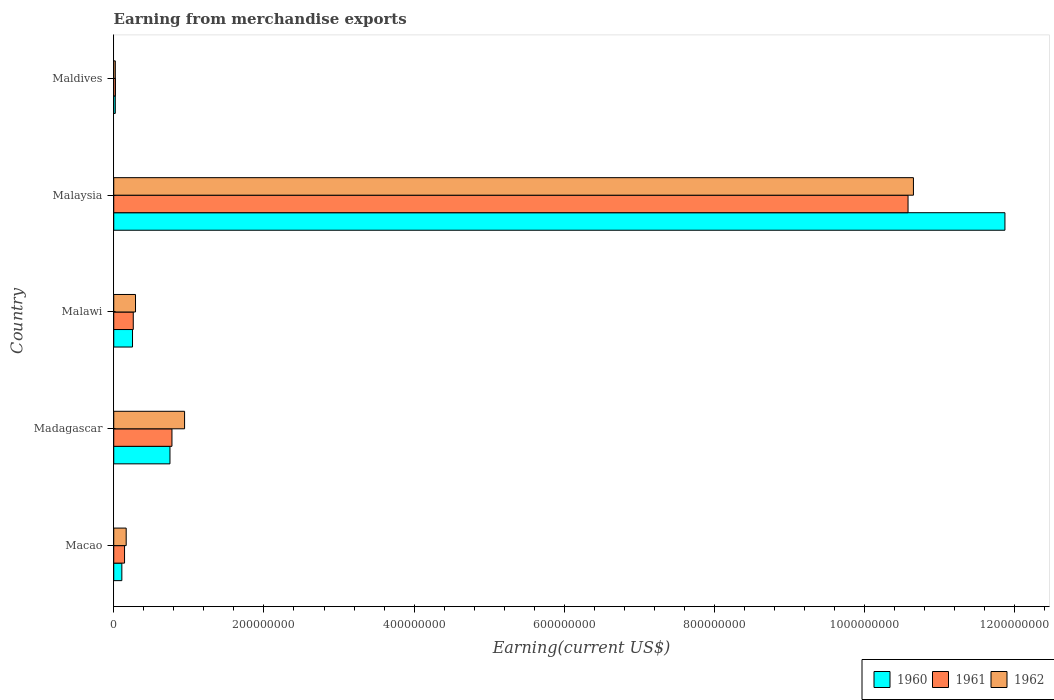How many different coloured bars are there?
Keep it short and to the point. 3. Are the number of bars per tick equal to the number of legend labels?
Provide a short and direct response. Yes. How many bars are there on the 3rd tick from the top?
Keep it short and to the point. 3. What is the label of the 4th group of bars from the top?
Offer a very short reply. Madagascar. What is the amount earned from merchandise exports in 1962 in Malaysia?
Your response must be concise. 1.06e+09. Across all countries, what is the maximum amount earned from merchandise exports in 1962?
Ensure brevity in your answer.  1.06e+09. Across all countries, what is the minimum amount earned from merchandise exports in 1962?
Offer a terse response. 2.08e+06. In which country was the amount earned from merchandise exports in 1960 maximum?
Your answer should be compact. Malaysia. In which country was the amount earned from merchandise exports in 1962 minimum?
Offer a terse response. Maldives. What is the total amount earned from merchandise exports in 1961 in the graph?
Your response must be concise. 1.18e+09. What is the difference between the amount earned from merchandise exports in 1960 in Madagascar and that in Malaysia?
Your response must be concise. -1.11e+09. What is the difference between the amount earned from merchandise exports in 1961 in Macao and the amount earned from merchandise exports in 1962 in Madagascar?
Offer a terse response. -7.99e+07. What is the average amount earned from merchandise exports in 1961 per country?
Your answer should be very brief. 2.36e+08. What is the difference between the amount earned from merchandise exports in 1961 and amount earned from merchandise exports in 1960 in Malaysia?
Offer a terse response. -1.29e+08. In how many countries, is the amount earned from merchandise exports in 1961 greater than 440000000 US$?
Provide a short and direct response. 1. What is the ratio of the amount earned from merchandise exports in 1961 in Macao to that in Malawi?
Keep it short and to the point. 0.55. What is the difference between the highest and the second highest amount earned from merchandise exports in 1962?
Provide a short and direct response. 9.71e+08. What is the difference between the highest and the lowest amount earned from merchandise exports in 1962?
Provide a short and direct response. 1.06e+09. What does the 1st bar from the bottom in Malaysia represents?
Offer a terse response. 1960. How many bars are there?
Make the answer very short. 15. How many countries are there in the graph?
Your response must be concise. 5. Are the values on the major ticks of X-axis written in scientific E-notation?
Provide a short and direct response. No. Does the graph contain any zero values?
Your answer should be very brief. No. Does the graph contain grids?
Offer a very short reply. No. Where does the legend appear in the graph?
Provide a succinct answer. Bottom right. How many legend labels are there?
Offer a terse response. 3. How are the legend labels stacked?
Your response must be concise. Horizontal. What is the title of the graph?
Your response must be concise. Earning from merchandise exports. Does "1991" appear as one of the legend labels in the graph?
Your answer should be compact. No. What is the label or title of the X-axis?
Your answer should be very brief. Earning(current US$). What is the Earning(current US$) in 1960 in Macao?
Give a very brief answer. 1.08e+07. What is the Earning(current US$) of 1961 in Macao?
Provide a short and direct response. 1.44e+07. What is the Earning(current US$) in 1962 in Macao?
Make the answer very short. 1.66e+07. What is the Earning(current US$) in 1960 in Madagascar?
Offer a very short reply. 7.49e+07. What is the Earning(current US$) in 1961 in Madagascar?
Your answer should be very brief. 7.75e+07. What is the Earning(current US$) in 1962 in Madagascar?
Your answer should be compact. 9.43e+07. What is the Earning(current US$) of 1960 in Malawi?
Give a very brief answer. 2.50e+07. What is the Earning(current US$) in 1961 in Malawi?
Make the answer very short. 2.60e+07. What is the Earning(current US$) of 1962 in Malawi?
Make the answer very short. 2.90e+07. What is the Earning(current US$) in 1960 in Malaysia?
Your response must be concise. 1.19e+09. What is the Earning(current US$) in 1961 in Malaysia?
Offer a very short reply. 1.06e+09. What is the Earning(current US$) of 1962 in Malaysia?
Your answer should be very brief. 1.06e+09. What is the Earning(current US$) in 1960 in Maldives?
Your answer should be compact. 2.07e+06. What is the Earning(current US$) of 1961 in Maldives?
Offer a terse response. 2.28e+06. What is the Earning(current US$) of 1962 in Maldives?
Give a very brief answer. 2.08e+06. Across all countries, what is the maximum Earning(current US$) in 1960?
Offer a terse response. 1.19e+09. Across all countries, what is the maximum Earning(current US$) of 1961?
Make the answer very short. 1.06e+09. Across all countries, what is the maximum Earning(current US$) of 1962?
Offer a terse response. 1.06e+09. Across all countries, what is the minimum Earning(current US$) of 1960?
Ensure brevity in your answer.  2.07e+06. Across all countries, what is the minimum Earning(current US$) in 1961?
Make the answer very short. 2.28e+06. Across all countries, what is the minimum Earning(current US$) of 1962?
Offer a terse response. 2.08e+06. What is the total Earning(current US$) of 1960 in the graph?
Your answer should be very brief. 1.30e+09. What is the total Earning(current US$) in 1961 in the graph?
Your answer should be compact. 1.18e+09. What is the total Earning(current US$) of 1962 in the graph?
Ensure brevity in your answer.  1.21e+09. What is the difference between the Earning(current US$) of 1960 in Macao and that in Madagascar?
Your response must be concise. -6.41e+07. What is the difference between the Earning(current US$) of 1961 in Macao and that in Madagascar?
Ensure brevity in your answer.  -6.31e+07. What is the difference between the Earning(current US$) of 1962 in Macao and that in Madagascar?
Provide a short and direct response. -7.78e+07. What is the difference between the Earning(current US$) in 1960 in Macao and that in Malawi?
Ensure brevity in your answer.  -1.42e+07. What is the difference between the Earning(current US$) of 1961 in Macao and that in Malawi?
Offer a terse response. -1.16e+07. What is the difference between the Earning(current US$) of 1962 in Macao and that in Malawi?
Make the answer very short. -1.24e+07. What is the difference between the Earning(current US$) in 1960 in Macao and that in Malaysia?
Your response must be concise. -1.18e+09. What is the difference between the Earning(current US$) in 1961 in Macao and that in Malaysia?
Your answer should be very brief. -1.04e+09. What is the difference between the Earning(current US$) in 1962 in Macao and that in Malaysia?
Make the answer very short. -1.05e+09. What is the difference between the Earning(current US$) in 1960 in Macao and that in Maldives?
Make the answer very short. 8.71e+06. What is the difference between the Earning(current US$) of 1961 in Macao and that in Maldives?
Offer a very short reply. 1.21e+07. What is the difference between the Earning(current US$) in 1962 in Macao and that in Maldives?
Your answer should be very brief. 1.45e+07. What is the difference between the Earning(current US$) of 1960 in Madagascar and that in Malawi?
Ensure brevity in your answer.  4.99e+07. What is the difference between the Earning(current US$) in 1961 in Madagascar and that in Malawi?
Keep it short and to the point. 5.15e+07. What is the difference between the Earning(current US$) of 1962 in Madagascar and that in Malawi?
Give a very brief answer. 6.53e+07. What is the difference between the Earning(current US$) of 1960 in Madagascar and that in Malaysia?
Offer a very short reply. -1.11e+09. What is the difference between the Earning(current US$) in 1961 in Madagascar and that in Malaysia?
Give a very brief answer. -9.80e+08. What is the difference between the Earning(current US$) of 1962 in Madagascar and that in Malaysia?
Provide a short and direct response. -9.71e+08. What is the difference between the Earning(current US$) of 1960 in Madagascar and that in Maldives?
Your answer should be compact. 7.28e+07. What is the difference between the Earning(current US$) in 1961 in Madagascar and that in Maldives?
Offer a terse response. 7.52e+07. What is the difference between the Earning(current US$) of 1962 in Madagascar and that in Maldives?
Your answer should be compact. 9.22e+07. What is the difference between the Earning(current US$) in 1960 in Malawi and that in Malaysia?
Make the answer very short. -1.16e+09. What is the difference between the Earning(current US$) in 1961 in Malawi and that in Malaysia?
Your answer should be very brief. -1.03e+09. What is the difference between the Earning(current US$) in 1962 in Malawi and that in Malaysia?
Give a very brief answer. -1.04e+09. What is the difference between the Earning(current US$) of 1960 in Malawi and that in Maldives?
Your answer should be very brief. 2.29e+07. What is the difference between the Earning(current US$) of 1961 in Malawi and that in Maldives?
Ensure brevity in your answer.  2.37e+07. What is the difference between the Earning(current US$) of 1962 in Malawi and that in Maldives?
Keep it short and to the point. 2.69e+07. What is the difference between the Earning(current US$) in 1960 in Malaysia and that in Maldives?
Your response must be concise. 1.18e+09. What is the difference between the Earning(current US$) in 1961 in Malaysia and that in Maldives?
Provide a succinct answer. 1.06e+09. What is the difference between the Earning(current US$) in 1962 in Malaysia and that in Maldives?
Your answer should be very brief. 1.06e+09. What is the difference between the Earning(current US$) of 1960 in Macao and the Earning(current US$) of 1961 in Madagascar?
Provide a short and direct response. -6.67e+07. What is the difference between the Earning(current US$) of 1960 in Macao and the Earning(current US$) of 1962 in Madagascar?
Offer a terse response. -8.36e+07. What is the difference between the Earning(current US$) in 1961 in Macao and the Earning(current US$) in 1962 in Madagascar?
Your answer should be very brief. -7.99e+07. What is the difference between the Earning(current US$) of 1960 in Macao and the Earning(current US$) of 1961 in Malawi?
Your answer should be very brief. -1.52e+07. What is the difference between the Earning(current US$) in 1960 in Macao and the Earning(current US$) in 1962 in Malawi?
Offer a very short reply. -1.82e+07. What is the difference between the Earning(current US$) in 1961 in Macao and the Earning(current US$) in 1962 in Malawi?
Keep it short and to the point. -1.46e+07. What is the difference between the Earning(current US$) in 1960 in Macao and the Earning(current US$) in 1961 in Malaysia?
Provide a short and direct response. -1.05e+09. What is the difference between the Earning(current US$) of 1960 in Macao and the Earning(current US$) of 1962 in Malaysia?
Offer a very short reply. -1.05e+09. What is the difference between the Earning(current US$) of 1961 in Macao and the Earning(current US$) of 1962 in Malaysia?
Your answer should be very brief. -1.05e+09. What is the difference between the Earning(current US$) in 1960 in Macao and the Earning(current US$) in 1961 in Maldives?
Your answer should be very brief. 8.50e+06. What is the difference between the Earning(current US$) of 1960 in Macao and the Earning(current US$) of 1962 in Maldives?
Your answer should be compact. 8.70e+06. What is the difference between the Earning(current US$) in 1961 in Macao and the Earning(current US$) in 1962 in Maldives?
Provide a succinct answer. 1.23e+07. What is the difference between the Earning(current US$) in 1960 in Madagascar and the Earning(current US$) in 1961 in Malawi?
Give a very brief answer. 4.89e+07. What is the difference between the Earning(current US$) in 1960 in Madagascar and the Earning(current US$) in 1962 in Malawi?
Your response must be concise. 4.59e+07. What is the difference between the Earning(current US$) of 1961 in Madagascar and the Earning(current US$) of 1962 in Malawi?
Your answer should be very brief. 4.85e+07. What is the difference between the Earning(current US$) of 1960 in Madagascar and the Earning(current US$) of 1961 in Malaysia?
Offer a very short reply. -9.83e+08. What is the difference between the Earning(current US$) of 1960 in Madagascar and the Earning(current US$) of 1962 in Malaysia?
Provide a short and direct response. -9.90e+08. What is the difference between the Earning(current US$) in 1961 in Madagascar and the Earning(current US$) in 1962 in Malaysia?
Your answer should be compact. -9.87e+08. What is the difference between the Earning(current US$) in 1960 in Madagascar and the Earning(current US$) in 1961 in Maldives?
Your answer should be very brief. 7.26e+07. What is the difference between the Earning(current US$) of 1960 in Madagascar and the Earning(current US$) of 1962 in Maldives?
Ensure brevity in your answer.  7.28e+07. What is the difference between the Earning(current US$) of 1961 in Madagascar and the Earning(current US$) of 1962 in Maldives?
Provide a short and direct response. 7.54e+07. What is the difference between the Earning(current US$) of 1960 in Malawi and the Earning(current US$) of 1961 in Malaysia?
Provide a short and direct response. -1.03e+09. What is the difference between the Earning(current US$) in 1960 in Malawi and the Earning(current US$) in 1962 in Malaysia?
Offer a very short reply. -1.04e+09. What is the difference between the Earning(current US$) of 1961 in Malawi and the Earning(current US$) of 1962 in Malaysia?
Keep it short and to the point. -1.04e+09. What is the difference between the Earning(current US$) of 1960 in Malawi and the Earning(current US$) of 1961 in Maldives?
Keep it short and to the point. 2.27e+07. What is the difference between the Earning(current US$) in 1960 in Malawi and the Earning(current US$) in 1962 in Maldives?
Your response must be concise. 2.29e+07. What is the difference between the Earning(current US$) in 1961 in Malawi and the Earning(current US$) in 1962 in Maldives?
Provide a succinct answer. 2.39e+07. What is the difference between the Earning(current US$) of 1960 in Malaysia and the Earning(current US$) of 1961 in Maldives?
Provide a short and direct response. 1.18e+09. What is the difference between the Earning(current US$) of 1960 in Malaysia and the Earning(current US$) of 1962 in Maldives?
Provide a succinct answer. 1.18e+09. What is the difference between the Earning(current US$) of 1961 in Malaysia and the Earning(current US$) of 1962 in Maldives?
Your answer should be compact. 1.06e+09. What is the average Earning(current US$) in 1960 per country?
Offer a terse response. 2.60e+08. What is the average Earning(current US$) in 1961 per country?
Offer a terse response. 2.36e+08. What is the average Earning(current US$) in 1962 per country?
Ensure brevity in your answer.  2.41e+08. What is the difference between the Earning(current US$) of 1960 and Earning(current US$) of 1961 in Macao?
Make the answer very short. -3.62e+06. What is the difference between the Earning(current US$) of 1960 and Earning(current US$) of 1962 in Macao?
Ensure brevity in your answer.  -5.80e+06. What is the difference between the Earning(current US$) in 1961 and Earning(current US$) in 1962 in Macao?
Give a very brief answer. -2.18e+06. What is the difference between the Earning(current US$) in 1960 and Earning(current US$) in 1961 in Madagascar?
Give a very brief answer. -2.65e+06. What is the difference between the Earning(current US$) in 1960 and Earning(current US$) in 1962 in Madagascar?
Provide a short and direct response. -1.94e+07. What is the difference between the Earning(current US$) of 1961 and Earning(current US$) of 1962 in Madagascar?
Your answer should be very brief. -1.68e+07. What is the difference between the Earning(current US$) of 1960 and Earning(current US$) of 1961 in Malawi?
Provide a succinct answer. -1.00e+06. What is the difference between the Earning(current US$) of 1960 and Earning(current US$) of 1962 in Malawi?
Ensure brevity in your answer.  -4.00e+06. What is the difference between the Earning(current US$) of 1960 and Earning(current US$) of 1961 in Malaysia?
Your answer should be compact. 1.29e+08. What is the difference between the Earning(current US$) in 1960 and Earning(current US$) in 1962 in Malaysia?
Offer a terse response. 1.22e+08. What is the difference between the Earning(current US$) in 1961 and Earning(current US$) in 1962 in Malaysia?
Ensure brevity in your answer.  -7.18e+06. What is the difference between the Earning(current US$) in 1960 and Earning(current US$) in 1961 in Maldives?
Provide a succinct answer. -2.04e+05. What is the difference between the Earning(current US$) of 1960 and Earning(current US$) of 1962 in Maldives?
Your response must be concise. -8190. What is the difference between the Earning(current US$) of 1961 and Earning(current US$) of 1962 in Maldives?
Make the answer very short. 1.96e+05. What is the ratio of the Earning(current US$) of 1960 in Macao to that in Madagascar?
Your response must be concise. 0.14. What is the ratio of the Earning(current US$) of 1961 in Macao to that in Madagascar?
Your response must be concise. 0.19. What is the ratio of the Earning(current US$) in 1962 in Macao to that in Madagascar?
Your answer should be very brief. 0.18. What is the ratio of the Earning(current US$) in 1960 in Macao to that in Malawi?
Offer a terse response. 0.43. What is the ratio of the Earning(current US$) in 1961 in Macao to that in Malawi?
Make the answer very short. 0.55. What is the ratio of the Earning(current US$) of 1962 in Macao to that in Malawi?
Offer a terse response. 0.57. What is the ratio of the Earning(current US$) of 1960 in Macao to that in Malaysia?
Provide a short and direct response. 0.01. What is the ratio of the Earning(current US$) of 1961 in Macao to that in Malaysia?
Give a very brief answer. 0.01. What is the ratio of the Earning(current US$) in 1962 in Macao to that in Malaysia?
Your response must be concise. 0.02. What is the ratio of the Earning(current US$) in 1960 in Macao to that in Maldives?
Give a very brief answer. 5.2. What is the ratio of the Earning(current US$) in 1961 in Macao to that in Maldives?
Ensure brevity in your answer.  6.32. What is the ratio of the Earning(current US$) in 1962 in Macao to that in Maldives?
Provide a succinct answer. 7.96. What is the ratio of the Earning(current US$) of 1960 in Madagascar to that in Malawi?
Make the answer very short. 3. What is the ratio of the Earning(current US$) in 1961 in Madagascar to that in Malawi?
Keep it short and to the point. 2.98. What is the ratio of the Earning(current US$) of 1962 in Madagascar to that in Malawi?
Provide a short and direct response. 3.25. What is the ratio of the Earning(current US$) of 1960 in Madagascar to that in Malaysia?
Your answer should be very brief. 0.06. What is the ratio of the Earning(current US$) in 1961 in Madagascar to that in Malaysia?
Make the answer very short. 0.07. What is the ratio of the Earning(current US$) in 1962 in Madagascar to that in Malaysia?
Offer a very short reply. 0.09. What is the ratio of the Earning(current US$) of 1960 in Madagascar to that in Maldives?
Provide a short and direct response. 36.1. What is the ratio of the Earning(current US$) of 1961 in Madagascar to that in Maldives?
Provide a succinct answer. 34.03. What is the ratio of the Earning(current US$) of 1962 in Madagascar to that in Maldives?
Offer a terse response. 45.3. What is the ratio of the Earning(current US$) in 1960 in Malawi to that in Malaysia?
Offer a terse response. 0.02. What is the ratio of the Earning(current US$) in 1961 in Malawi to that in Malaysia?
Your response must be concise. 0.02. What is the ratio of the Earning(current US$) of 1962 in Malawi to that in Malaysia?
Provide a succinct answer. 0.03. What is the ratio of the Earning(current US$) in 1960 in Malawi to that in Maldives?
Keep it short and to the point. 12.05. What is the ratio of the Earning(current US$) in 1961 in Malawi to that in Maldives?
Ensure brevity in your answer.  11.41. What is the ratio of the Earning(current US$) of 1962 in Malawi to that in Maldives?
Give a very brief answer. 13.93. What is the ratio of the Earning(current US$) of 1960 in Malaysia to that in Maldives?
Give a very brief answer. 572.11. What is the ratio of the Earning(current US$) of 1961 in Malaysia to that in Maldives?
Ensure brevity in your answer.  464.32. What is the ratio of the Earning(current US$) of 1962 in Malaysia to that in Maldives?
Keep it short and to the point. 511.35. What is the difference between the highest and the second highest Earning(current US$) of 1960?
Your answer should be compact. 1.11e+09. What is the difference between the highest and the second highest Earning(current US$) in 1961?
Provide a succinct answer. 9.80e+08. What is the difference between the highest and the second highest Earning(current US$) in 1962?
Keep it short and to the point. 9.71e+08. What is the difference between the highest and the lowest Earning(current US$) in 1960?
Offer a very short reply. 1.18e+09. What is the difference between the highest and the lowest Earning(current US$) of 1961?
Offer a very short reply. 1.06e+09. What is the difference between the highest and the lowest Earning(current US$) of 1962?
Ensure brevity in your answer.  1.06e+09. 